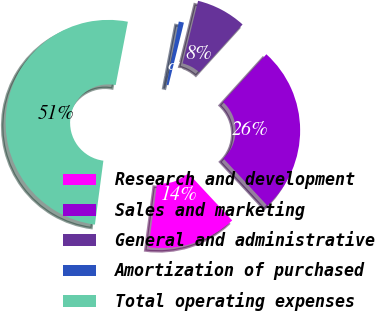Convert chart to OTSL. <chart><loc_0><loc_0><loc_500><loc_500><pie_chart><fcel>Research and development<fcel>Sales and marketing<fcel>General and administrative<fcel>Amortization of purchased<fcel>Total operating expenses<nl><fcel>14.03%<fcel>26.34%<fcel>7.88%<fcel>0.81%<fcel>50.93%<nl></chart> 